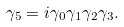<formula> <loc_0><loc_0><loc_500><loc_500>\gamma _ { 5 } = i \gamma _ { 0 } \gamma _ { 1 } \gamma _ { 2 } \gamma _ { 3 } .</formula> 